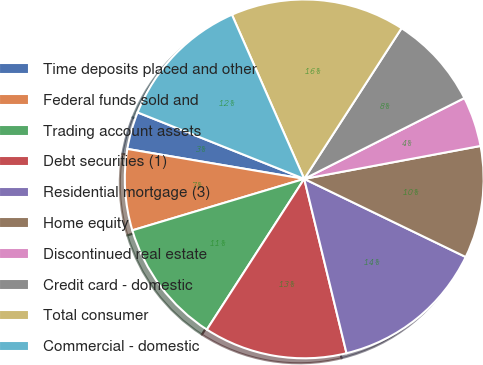<chart> <loc_0><loc_0><loc_500><loc_500><pie_chart><fcel>Time deposits placed and other<fcel>Federal funds sold and<fcel>Trading account assets<fcel>Debt securities (1)<fcel>Residential mortgage (3)<fcel>Home equity<fcel>Discontinued real estate<fcel>Credit card - domestic<fcel>Total consumer<fcel>Commercial - domestic<nl><fcel>3.37%<fcel>7.3%<fcel>11.24%<fcel>12.92%<fcel>14.04%<fcel>10.11%<fcel>4.5%<fcel>8.43%<fcel>15.73%<fcel>12.36%<nl></chart> 